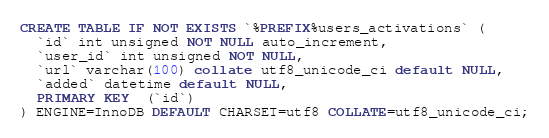<code> <loc_0><loc_0><loc_500><loc_500><_SQL_>CREATE TABLE IF NOT EXISTS `%PREFIX%users_activations` (
  `id` int unsigned NOT NULL auto_increment,
  `user_id` int unsigned NOT NULL,
  `url` varchar(100) collate utf8_unicode_ci default NULL,
  `added` datetime default NULL,
  PRIMARY KEY  (`id`)
) ENGINE=InnoDB DEFAULT CHARSET=utf8 COLLATE=utf8_unicode_ci;
</code> 